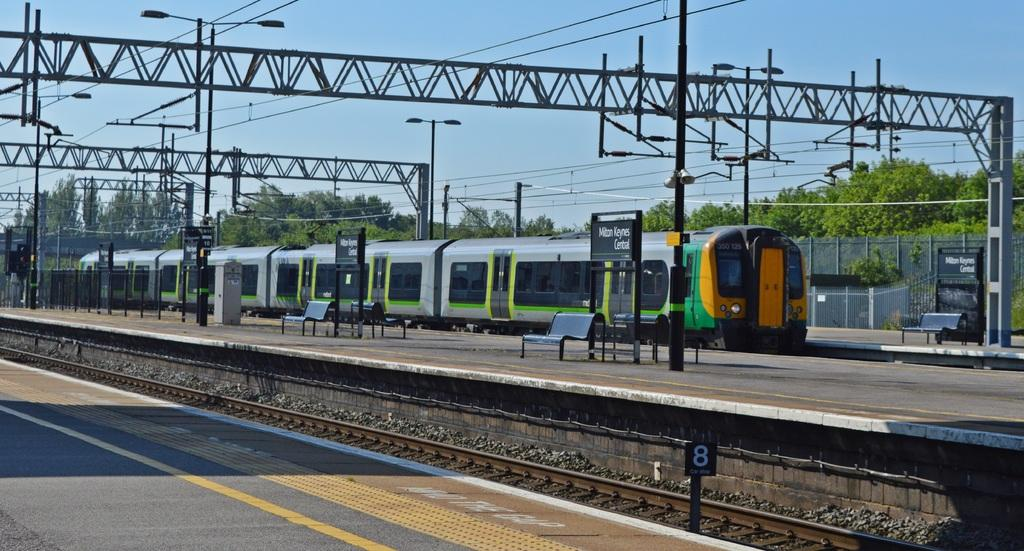What is the main subject of the image? The main subject of the image is a train. Where is the train located in the image? The train is on a platform. Are there any other platforms visible in the image? Yes, there are platforms on either side of the train. What can be seen above the train in the image? There is a metal arch above the train. What is visible in the background of the image? There are trees in the background of the image, and the sky is visible above the train and trees. How many sisters are present in the image? There are no sisters present in the image; it features a train on a platform with a metal arch and trees in the background. What answer can be seen written on the train? There is no answer written on the train in the image. 